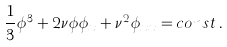<formula> <loc_0><loc_0><loc_500><loc_500>\frac { 1 } { 3 } { \phi } ^ { 3 } + 2 \nu { \phi } { \phi } _ { x } + \nu ^ { 2 } { \phi } _ { x x } = c o n s t \, .</formula> 